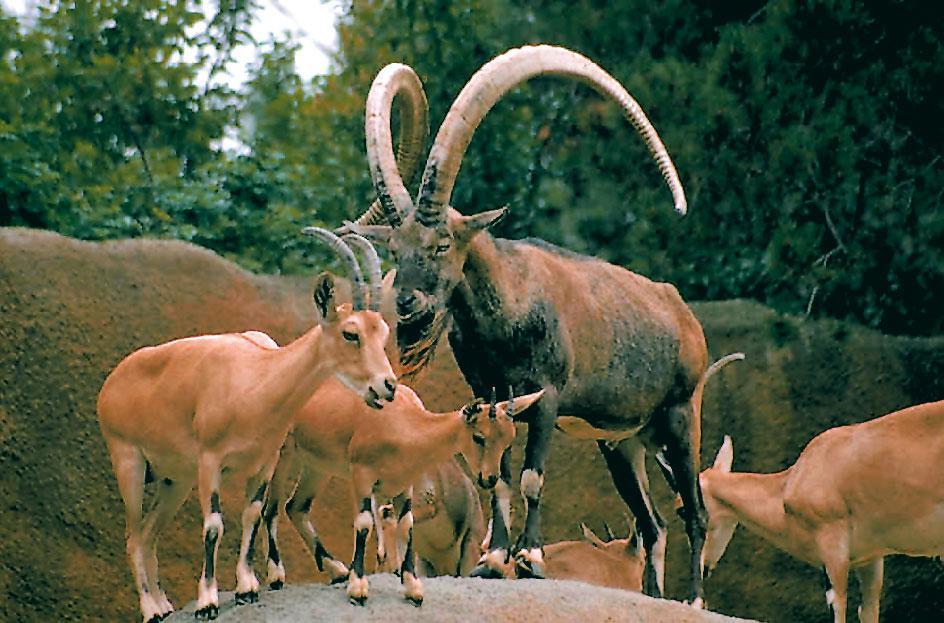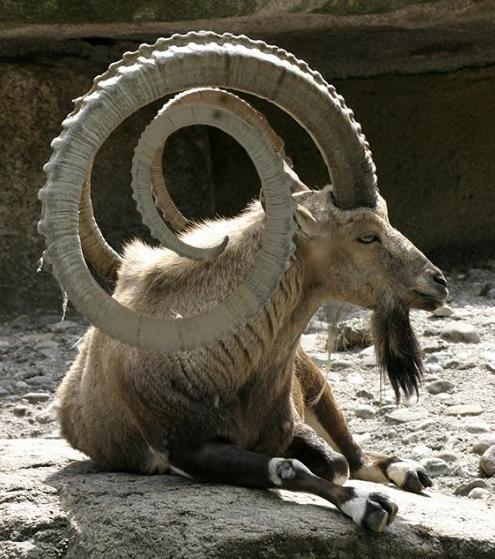The first image is the image on the left, the second image is the image on the right. Given the left and right images, does the statement "The left image contains one reclining long-horned goat, and the right image contains one long-horned goat standing in profile." hold true? Answer yes or no. No. The first image is the image on the left, the second image is the image on the right. Considering the images on both sides, is "An ibex is laying down in the left image." valid? Answer yes or no. No. 